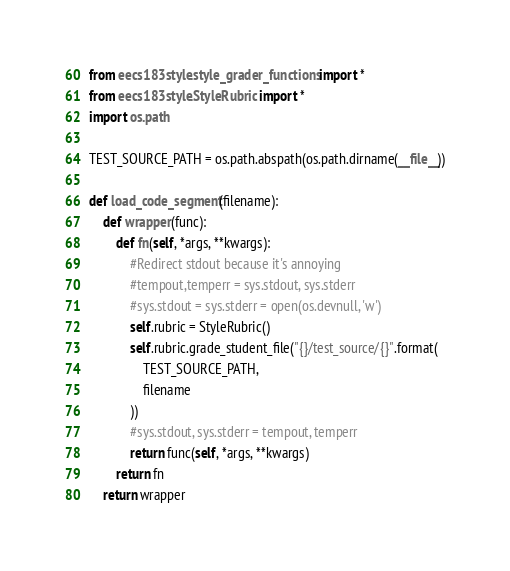<code> <loc_0><loc_0><loc_500><loc_500><_Python_>from eecs183style.style_grader_functions import *
from eecs183style.StyleRubric import *
import os.path

TEST_SOURCE_PATH = os.path.abspath(os.path.dirname(__file__))

def load_code_segment(filename):
    def wrapper(func):
        def fn(self, *args, **kwargs):
            #Redirect stdout because it's annoying
            #tempout,temperr = sys.stdout, sys.stderr
            #sys.stdout = sys.stderr = open(os.devnull, 'w')
            self.rubric = StyleRubric()
            self.rubric.grade_student_file("{}/test_source/{}".format(
                TEST_SOURCE_PATH,
                filename
            ))
            #sys.stdout, sys.stderr = tempout, temperr
            return func(self, *args, **kwargs)
        return fn
    return wrapper

</code> 